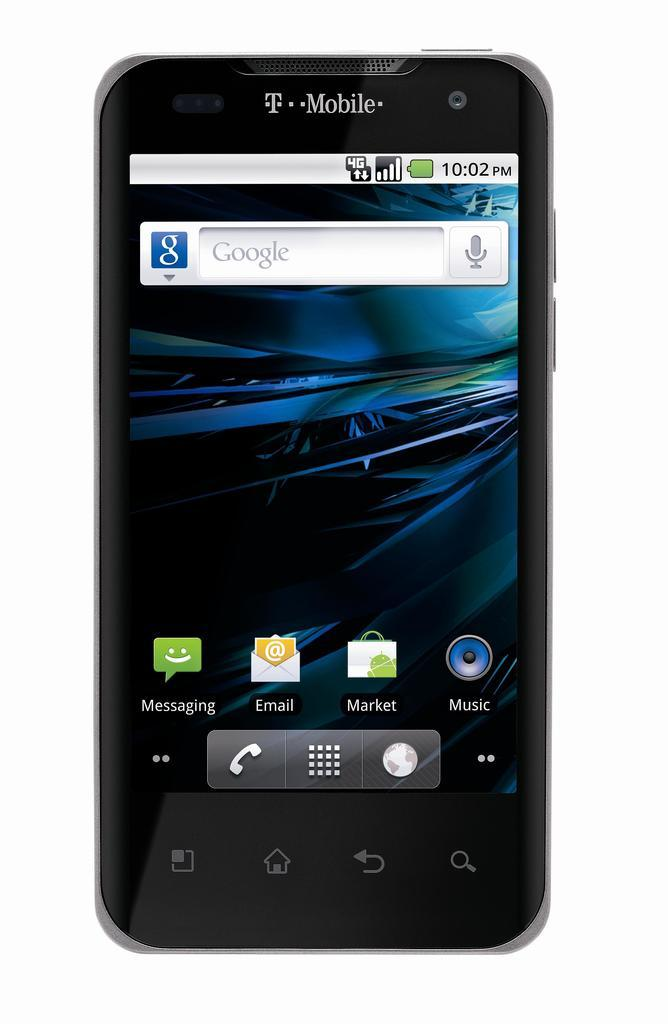<image>
Relay a brief, clear account of the picture shown. A T-Mobile cell phone has the time of 10:02 pm. 